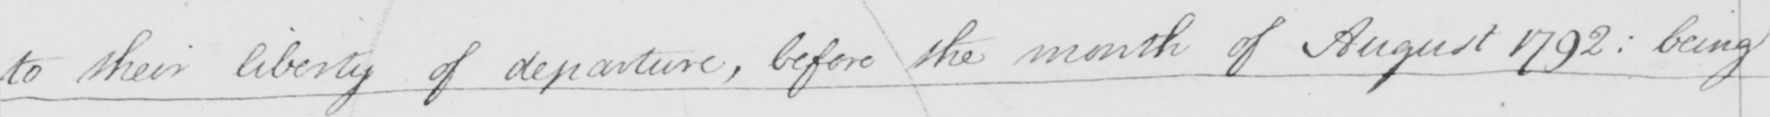What text is written in this handwritten line? to their liberty of departure , before the month of August 1792 :  being 